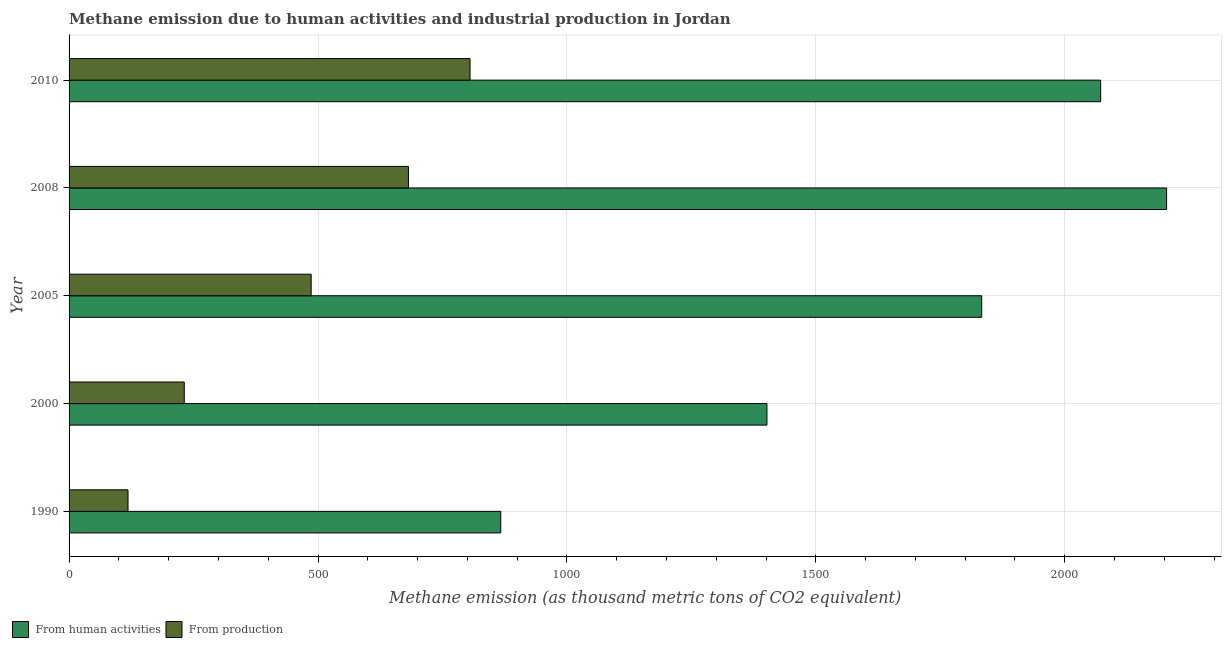Are the number of bars on each tick of the Y-axis equal?
Your answer should be compact. Yes. How many bars are there on the 5th tick from the bottom?
Give a very brief answer. 2. In how many cases, is the number of bars for a given year not equal to the number of legend labels?
Your response must be concise. 0. What is the amount of emissions generated from industries in 2005?
Offer a very short reply. 486.3. Across all years, what is the maximum amount of emissions generated from industries?
Ensure brevity in your answer.  805.4. Across all years, what is the minimum amount of emissions generated from industries?
Your answer should be compact. 118.4. In which year was the amount of emissions from human activities maximum?
Offer a very short reply. 2008. In which year was the amount of emissions generated from industries minimum?
Keep it short and to the point. 1990. What is the total amount of emissions generated from industries in the graph?
Offer a terse response. 2323.2. What is the difference between the amount of emissions from human activities in 1990 and that in 2000?
Provide a succinct answer. -534.7. What is the difference between the amount of emissions from human activities in 2008 and the amount of emissions generated from industries in 1990?
Provide a short and direct response. 2086.2. What is the average amount of emissions from human activities per year?
Provide a succinct answer. 1675.76. In the year 2010, what is the difference between the amount of emissions generated from industries and amount of emissions from human activities?
Offer a terse response. -1266.7. What is the ratio of the amount of emissions from human activities in 1990 to that in 2010?
Keep it short and to the point. 0.42. Is the amount of emissions generated from industries in 2005 less than that in 2008?
Provide a succinct answer. Yes. What is the difference between the highest and the second highest amount of emissions generated from industries?
Your response must be concise. 123.7. What is the difference between the highest and the lowest amount of emissions generated from industries?
Your answer should be compact. 687. In how many years, is the amount of emissions from human activities greater than the average amount of emissions from human activities taken over all years?
Offer a terse response. 3. What does the 1st bar from the top in 1990 represents?
Give a very brief answer. From production. What does the 2nd bar from the bottom in 1990 represents?
Your response must be concise. From production. How many bars are there?
Offer a very short reply. 10. How many years are there in the graph?
Ensure brevity in your answer.  5. What is the difference between two consecutive major ticks on the X-axis?
Provide a short and direct response. 500. Are the values on the major ticks of X-axis written in scientific E-notation?
Keep it short and to the point. No. Does the graph contain any zero values?
Your answer should be very brief. No. Does the graph contain grids?
Offer a very short reply. Yes. What is the title of the graph?
Offer a terse response. Methane emission due to human activities and industrial production in Jordan. What is the label or title of the X-axis?
Offer a terse response. Methane emission (as thousand metric tons of CO2 equivalent). What is the label or title of the Y-axis?
Your answer should be compact. Year. What is the Methane emission (as thousand metric tons of CO2 equivalent) of From human activities in 1990?
Your answer should be very brief. 867.1. What is the Methane emission (as thousand metric tons of CO2 equivalent) in From production in 1990?
Your answer should be compact. 118.4. What is the Methane emission (as thousand metric tons of CO2 equivalent) in From human activities in 2000?
Your answer should be very brief. 1401.8. What is the Methane emission (as thousand metric tons of CO2 equivalent) in From production in 2000?
Make the answer very short. 231.4. What is the Methane emission (as thousand metric tons of CO2 equivalent) of From human activities in 2005?
Offer a terse response. 1833.2. What is the Methane emission (as thousand metric tons of CO2 equivalent) in From production in 2005?
Offer a very short reply. 486.3. What is the Methane emission (as thousand metric tons of CO2 equivalent) of From human activities in 2008?
Offer a terse response. 2204.6. What is the Methane emission (as thousand metric tons of CO2 equivalent) in From production in 2008?
Your answer should be very brief. 681.7. What is the Methane emission (as thousand metric tons of CO2 equivalent) of From human activities in 2010?
Your response must be concise. 2072.1. What is the Methane emission (as thousand metric tons of CO2 equivalent) of From production in 2010?
Give a very brief answer. 805.4. Across all years, what is the maximum Methane emission (as thousand metric tons of CO2 equivalent) in From human activities?
Keep it short and to the point. 2204.6. Across all years, what is the maximum Methane emission (as thousand metric tons of CO2 equivalent) in From production?
Make the answer very short. 805.4. Across all years, what is the minimum Methane emission (as thousand metric tons of CO2 equivalent) in From human activities?
Ensure brevity in your answer.  867.1. Across all years, what is the minimum Methane emission (as thousand metric tons of CO2 equivalent) of From production?
Your response must be concise. 118.4. What is the total Methane emission (as thousand metric tons of CO2 equivalent) of From human activities in the graph?
Your response must be concise. 8378.8. What is the total Methane emission (as thousand metric tons of CO2 equivalent) in From production in the graph?
Your answer should be very brief. 2323.2. What is the difference between the Methane emission (as thousand metric tons of CO2 equivalent) in From human activities in 1990 and that in 2000?
Offer a terse response. -534.7. What is the difference between the Methane emission (as thousand metric tons of CO2 equivalent) in From production in 1990 and that in 2000?
Keep it short and to the point. -113. What is the difference between the Methane emission (as thousand metric tons of CO2 equivalent) of From human activities in 1990 and that in 2005?
Your answer should be compact. -966.1. What is the difference between the Methane emission (as thousand metric tons of CO2 equivalent) in From production in 1990 and that in 2005?
Keep it short and to the point. -367.9. What is the difference between the Methane emission (as thousand metric tons of CO2 equivalent) of From human activities in 1990 and that in 2008?
Offer a terse response. -1337.5. What is the difference between the Methane emission (as thousand metric tons of CO2 equivalent) of From production in 1990 and that in 2008?
Keep it short and to the point. -563.3. What is the difference between the Methane emission (as thousand metric tons of CO2 equivalent) of From human activities in 1990 and that in 2010?
Provide a short and direct response. -1205. What is the difference between the Methane emission (as thousand metric tons of CO2 equivalent) of From production in 1990 and that in 2010?
Ensure brevity in your answer.  -687. What is the difference between the Methane emission (as thousand metric tons of CO2 equivalent) of From human activities in 2000 and that in 2005?
Keep it short and to the point. -431.4. What is the difference between the Methane emission (as thousand metric tons of CO2 equivalent) of From production in 2000 and that in 2005?
Your answer should be very brief. -254.9. What is the difference between the Methane emission (as thousand metric tons of CO2 equivalent) of From human activities in 2000 and that in 2008?
Offer a terse response. -802.8. What is the difference between the Methane emission (as thousand metric tons of CO2 equivalent) of From production in 2000 and that in 2008?
Make the answer very short. -450.3. What is the difference between the Methane emission (as thousand metric tons of CO2 equivalent) in From human activities in 2000 and that in 2010?
Ensure brevity in your answer.  -670.3. What is the difference between the Methane emission (as thousand metric tons of CO2 equivalent) of From production in 2000 and that in 2010?
Ensure brevity in your answer.  -574. What is the difference between the Methane emission (as thousand metric tons of CO2 equivalent) of From human activities in 2005 and that in 2008?
Your answer should be compact. -371.4. What is the difference between the Methane emission (as thousand metric tons of CO2 equivalent) of From production in 2005 and that in 2008?
Offer a terse response. -195.4. What is the difference between the Methane emission (as thousand metric tons of CO2 equivalent) of From human activities in 2005 and that in 2010?
Give a very brief answer. -238.9. What is the difference between the Methane emission (as thousand metric tons of CO2 equivalent) in From production in 2005 and that in 2010?
Provide a succinct answer. -319.1. What is the difference between the Methane emission (as thousand metric tons of CO2 equivalent) of From human activities in 2008 and that in 2010?
Offer a terse response. 132.5. What is the difference between the Methane emission (as thousand metric tons of CO2 equivalent) in From production in 2008 and that in 2010?
Give a very brief answer. -123.7. What is the difference between the Methane emission (as thousand metric tons of CO2 equivalent) in From human activities in 1990 and the Methane emission (as thousand metric tons of CO2 equivalent) in From production in 2000?
Your answer should be very brief. 635.7. What is the difference between the Methane emission (as thousand metric tons of CO2 equivalent) of From human activities in 1990 and the Methane emission (as thousand metric tons of CO2 equivalent) of From production in 2005?
Offer a very short reply. 380.8. What is the difference between the Methane emission (as thousand metric tons of CO2 equivalent) of From human activities in 1990 and the Methane emission (as thousand metric tons of CO2 equivalent) of From production in 2008?
Your answer should be very brief. 185.4. What is the difference between the Methane emission (as thousand metric tons of CO2 equivalent) of From human activities in 1990 and the Methane emission (as thousand metric tons of CO2 equivalent) of From production in 2010?
Offer a very short reply. 61.7. What is the difference between the Methane emission (as thousand metric tons of CO2 equivalent) of From human activities in 2000 and the Methane emission (as thousand metric tons of CO2 equivalent) of From production in 2005?
Make the answer very short. 915.5. What is the difference between the Methane emission (as thousand metric tons of CO2 equivalent) in From human activities in 2000 and the Methane emission (as thousand metric tons of CO2 equivalent) in From production in 2008?
Your answer should be compact. 720.1. What is the difference between the Methane emission (as thousand metric tons of CO2 equivalent) in From human activities in 2000 and the Methane emission (as thousand metric tons of CO2 equivalent) in From production in 2010?
Ensure brevity in your answer.  596.4. What is the difference between the Methane emission (as thousand metric tons of CO2 equivalent) of From human activities in 2005 and the Methane emission (as thousand metric tons of CO2 equivalent) of From production in 2008?
Your answer should be compact. 1151.5. What is the difference between the Methane emission (as thousand metric tons of CO2 equivalent) of From human activities in 2005 and the Methane emission (as thousand metric tons of CO2 equivalent) of From production in 2010?
Your answer should be compact. 1027.8. What is the difference between the Methane emission (as thousand metric tons of CO2 equivalent) in From human activities in 2008 and the Methane emission (as thousand metric tons of CO2 equivalent) in From production in 2010?
Give a very brief answer. 1399.2. What is the average Methane emission (as thousand metric tons of CO2 equivalent) of From human activities per year?
Keep it short and to the point. 1675.76. What is the average Methane emission (as thousand metric tons of CO2 equivalent) in From production per year?
Give a very brief answer. 464.64. In the year 1990, what is the difference between the Methane emission (as thousand metric tons of CO2 equivalent) of From human activities and Methane emission (as thousand metric tons of CO2 equivalent) of From production?
Ensure brevity in your answer.  748.7. In the year 2000, what is the difference between the Methane emission (as thousand metric tons of CO2 equivalent) in From human activities and Methane emission (as thousand metric tons of CO2 equivalent) in From production?
Your response must be concise. 1170.4. In the year 2005, what is the difference between the Methane emission (as thousand metric tons of CO2 equivalent) of From human activities and Methane emission (as thousand metric tons of CO2 equivalent) of From production?
Your response must be concise. 1346.9. In the year 2008, what is the difference between the Methane emission (as thousand metric tons of CO2 equivalent) in From human activities and Methane emission (as thousand metric tons of CO2 equivalent) in From production?
Provide a succinct answer. 1522.9. In the year 2010, what is the difference between the Methane emission (as thousand metric tons of CO2 equivalent) in From human activities and Methane emission (as thousand metric tons of CO2 equivalent) in From production?
Keep it short and to the point. 1266.7. What is the ratio of the Methane emission (as thousand metric tons of CO2 equivalent) in From human activities in 1990 to that in 2000?
Your answer should be compact. 0.62. What is the ratio of the Methane emission (as thousand metric tons of CO2 equivalent) of From production in 1990 to that in 2000?
Your response must be concise. 0.51. What is the ratio of the Methane emission (as thousand metric tons of CO2 equivalent) in From human activities in 1990 to that in 2005?
Your response must be concise. 0.47. What is the ratio of the Methane emission (as thousand metric tons of CO2 equivalent) in From production in 1990 to that in 2005?
Provide a succinct answer. 0.24. What is the ratio of the Methane emission (as thousand metric tons of CO2 equivalent) of From human activities in 1990 to that in 2008?
Keep it short and to the point. 0.39. What is the ratio of the Methane emission (as thousand metric tons of CO2 equivalent) in From production in 1990 to that in 2008?
Offer a terse response. 0.17. What is the ratio of the Methane emission (as thousand metric tons of CO2 equivalent) in From human activities in 1990 to that in 2010?
Provide a succinct answer. 0.42. What is the ratio of the Methane emission (as thousand metric tons of CO2 equivalent) of From production in 1990 to that in 2010?
Your answer should be compact. 0.15. What is the ratio of the Methane emission (as thousand metric tons of CO2 equivalent) in From human activities in 2000 to that in 2005?
Your answer should be compact. 0.76. What is the ratio of the Methane emission (as thousand metric tons of CO2 equivalent) of From production in 2000 to that in 2005?
Ensure brevity in your answer.  0.48. What is the ratio of the Methane emission (as thousand metric tons of CO2 equivalent) in From human activities in 2000 to that in 2008?
Offer a very short reply. 0.64. What is the ratio of the Methane emission (as thousand metric tons of CO2 equivalent) in From production in 2000 to that in 2008?
Provide a short and direct response. 0.34. What is the ratio of the Methane emission (as thousand metric tons of CO2 equivalent) in From human activities in 2000 to that in 2010?
Offer a terse response. 0.68. What is the ratio of the Methane emission (as thousand metric tons of CO2 equivalent) of From production in 2000 to that in 2010?
Offer a terse response. 0.29. What is the ratio of the Methane emission (as thousand metric tons of CO2 equivalent) of From human activities in 2005 to that in 2008?
Provide a succinct answer. 0.83. What is the ratio of the Methane emission (as thousand metric tons of CO2 equivalent) in From production in 2005 to that in 2008?
Your response must be concise. 0.71. What is the ratio of the Methane emission (as thousand metric tons of CO2 equivalent) of From human activities in 2005 to that in 2010?
Provide a succinct answer. 0.88. What is the ratio of the Methane emission (as thousand metric tons of CO2 equivalent) in From production in 2005 to that in 2010?
Provide a short and direct response. 0.6. What is the ratio of the Methane emission (as thousand metric tons of CO2 equivalent) of From human activities in 2008 to that in 2010?
Your answer should be very brief. 1.06. What is the ratio of the Methane emission (as thousand metric tons of CO2 equivalent) in From production in 2008 to that in 2010?
Give a very brief answer. 0.85. What is the difference between the highest and the second highest Methane emission (as thousand metric tons of CO2 equivalent) in From human activities?
Give a very brief answer. 132.5. What is the difference between the highest and the second highest Methane emission (as thousand metric tons of CO2 equivalent) of From production?
Keep it short and to the point. 123.7. What is the difference between the highest and the lowest Methane emission (as thousand metric tons of CO2 equivalent) in From human activities?
Offer a terse response. 1337.5. What is the difference between the highest and the lowest Methane emission (as thousand metric tons of CO2 equivalent) in From production?
Give a very brief answer. 687. 